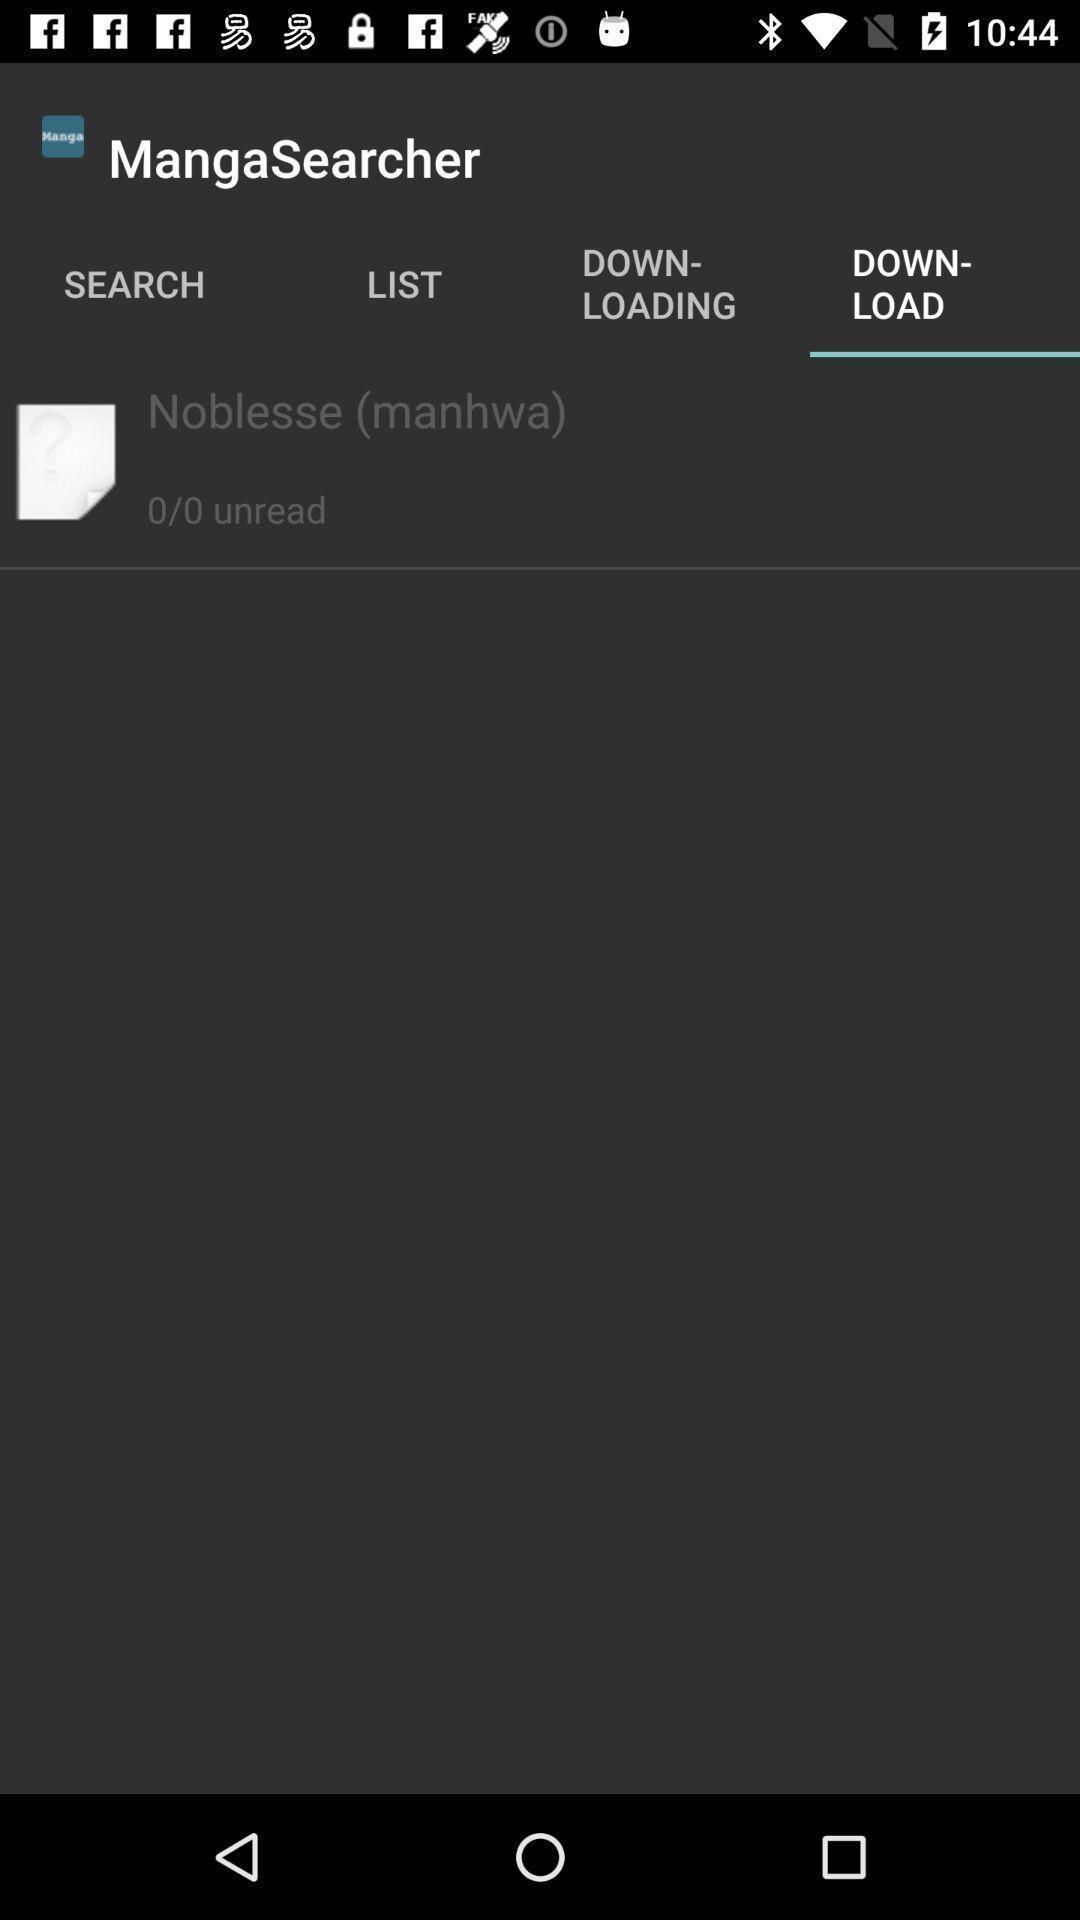Please provide a description for this image. Screen showing download. 